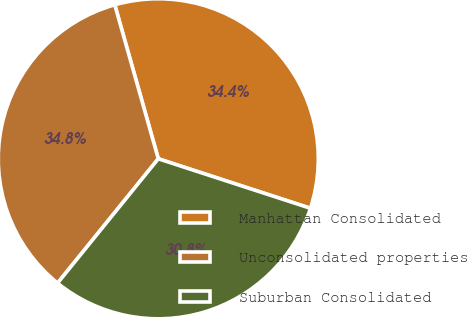Convert chart. <chart><loc_0><loc_0><loc_500><loc_500><pie_chart><fcel>Manhattan Consolidated<fcel>Unconsolidated properties<fcel>Suburban Consolidated<nl><fcel>34.39%<fcel>34.78%<fcel>30.83%<nl></chart> 